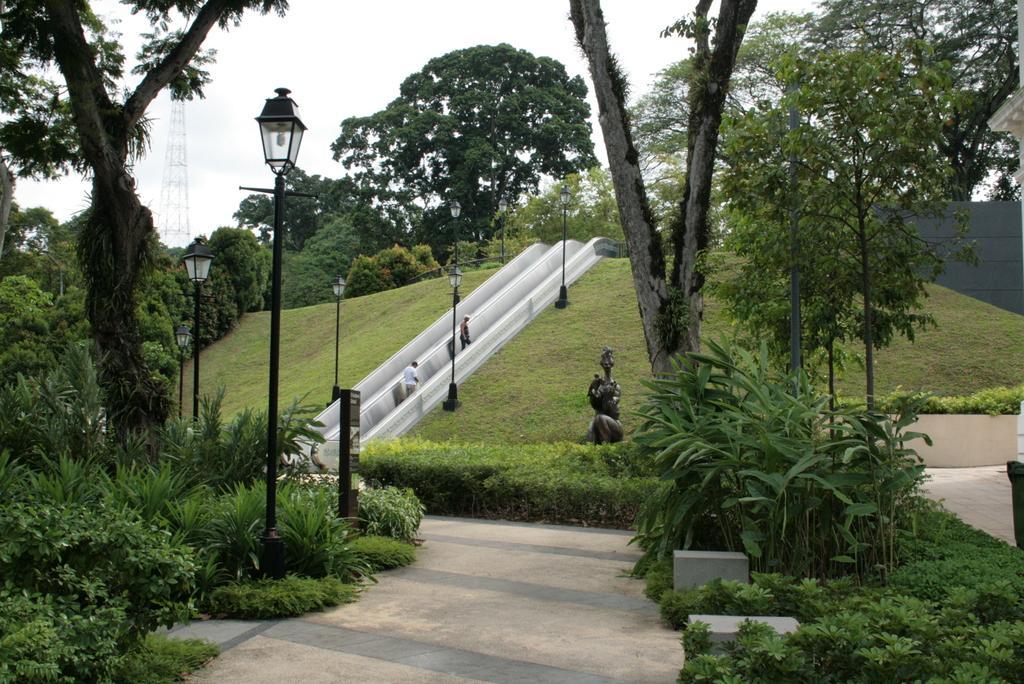Can you describe this image briefly? In the foreground of the picture there are plants, trees, street light, board, road and other objects. In the middle of the picture there are trees, sculpture, grass, streetlights, people, escalator and other objects. At the top we can see cell phone tower and sky. 